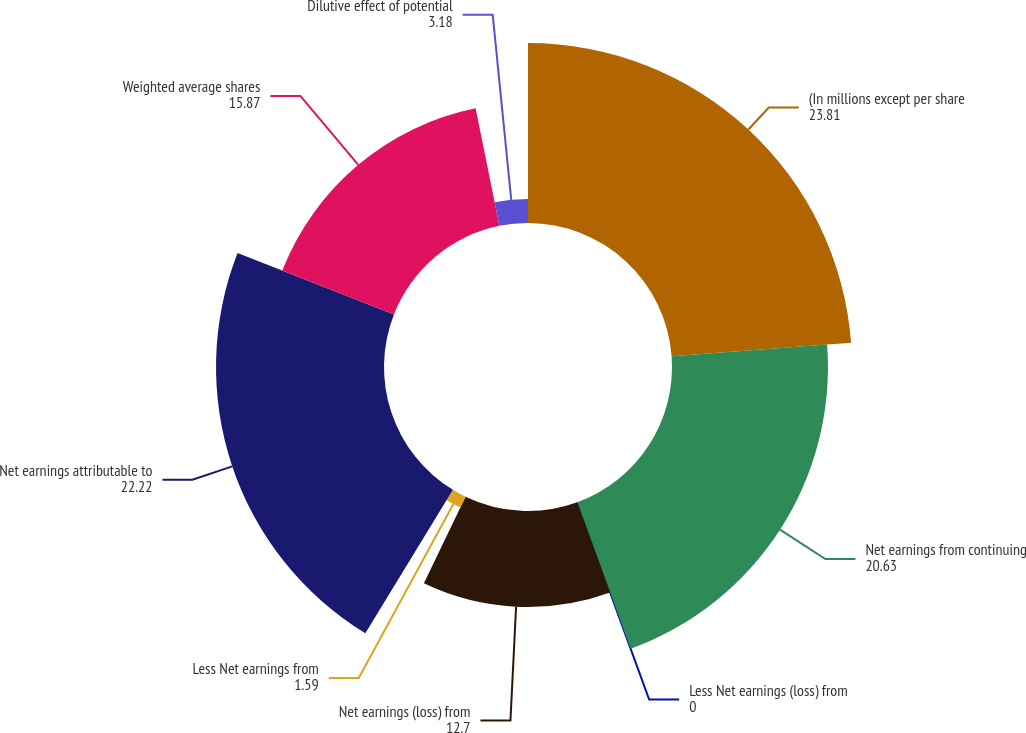Convert chart. <chart><loc_0><loc_0><loc_500><loc_500><pie_chart><fcel>(In millions except per share<fcel>Net earnings from continuing<fcel>Less Net earnings (loss) from<fcel>Net earnings (loss) from<fcel>Less Net earnings from<fcel>Net earnings attributable to<fcel>Weighted average shares<fcel>Dilutive effect of potential<nl><fcel>23.81%<fcel>20.63%<fcel>0.0%<fcel>12.7%<fcel>1.59%<fcel>22.22%<fcel>15.87%<fcel>3.18%<nl></chart> 